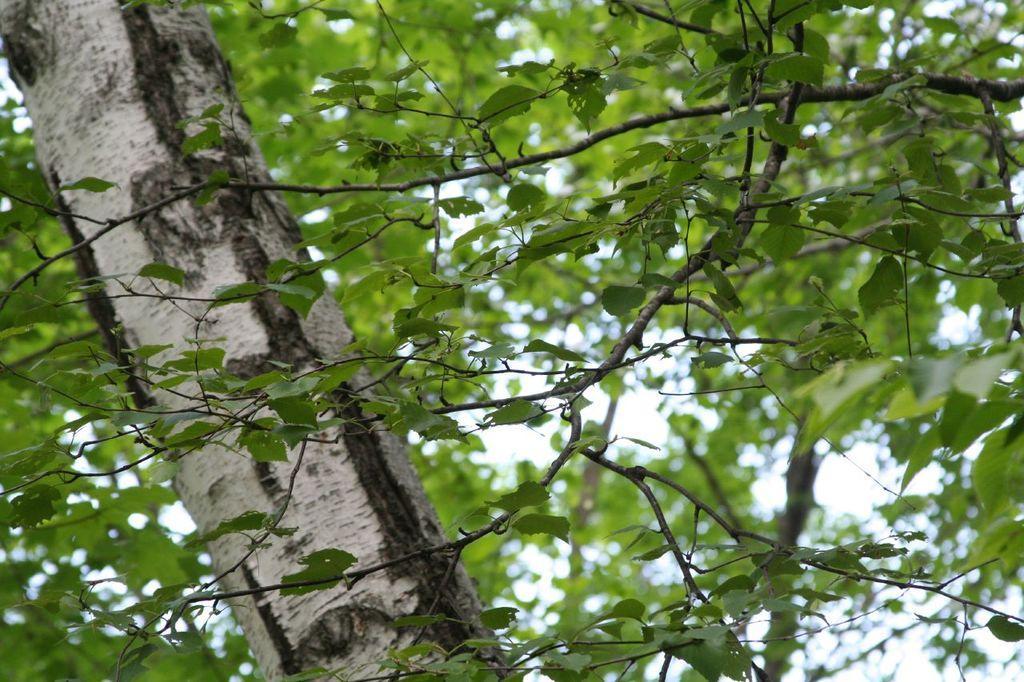Could you give a brief overview of what you see in this image? In the image there is a tree and around the tree trunk there are many branches. 